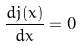Convert formula to latex. <formula><loc_0><loc_0><loc_500><loc_500>\frac { d j ( x ) } { d x } = 0</formula> 